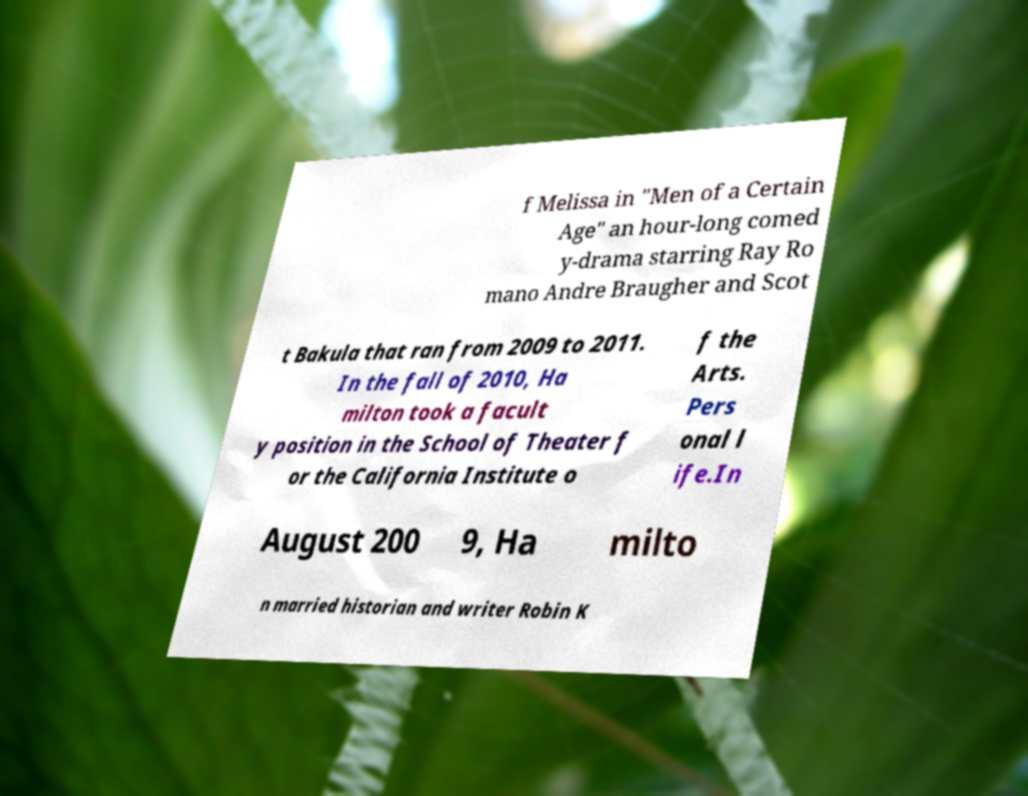There's text embedded in this image that I need extracted. Can you transcribe it verbatim? f Melissa in "Men of a Certain Age" an hour-long comed y-drama starring Ray Ro mano Andre Braugher and Scot t Bakula that ran from 2009 to 2011. In the fall of 2010, Ha milton took a facult y position in the School of Theater f or the California Institute o f the Arts. Pers onal l ife.In August 200 9, Ha milto n married historian and writer Robin K 